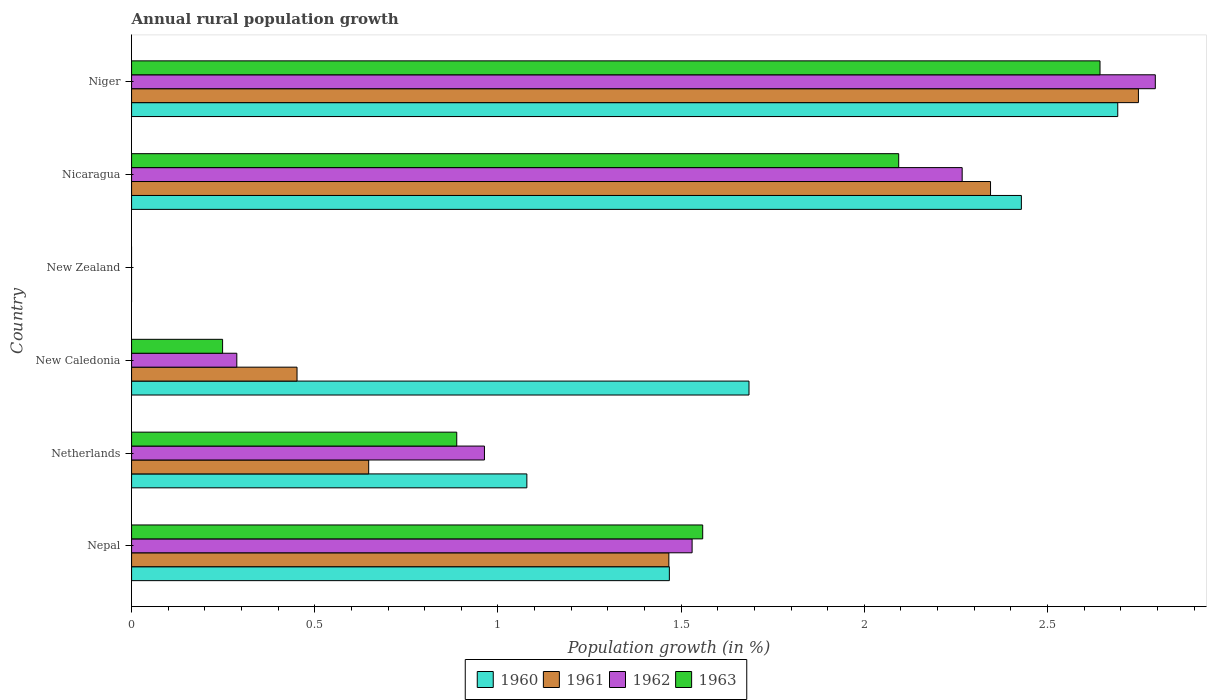How many different coloured bars are there?
Provide a short and direct response. 4. Are the number of bars per tick equal to the number of legend labels?
Provide a succinct answer. No. Are the number of bars on each tick of the Y-axis equal?
Offer a very short reply. No. How many bars are there on the 6th tick from the top?
Keep it short and to the point. 4. What is the label of the 4th group of bars from the top?
Give a very brief answer. New Caledonia. In how many cases, is the number of bars for a given country not equal to the number of legend labels?
Keep it short and to the point. 1. What is the percentage of rural population growth in 1963 in New Caledonia?
Ensure brevity in your answer.  0.25. Across all countries, what is the maximum percentage of rural population growth in 1962?
Give a very brief answer. 2.79. In which country was the percentage of rural population growth in 1962 maximum?
Ensure brevity in your answer.  Niger. What is the total percentage of rural population growth in 1963 in the graph?
Provide a succinct answer. 7.43. What is the difference between the percentage of rural population growth in 1963 in Netherlands and that in New Caledonia?
Provide a short and direct response. 0.64. What is the difference between the percentage of rural population growth in 1961 in New Zealand and the percentage of rural population growth in 1963 in New Caledonia?
Provide a short and direct response. -0.25. What is the average percentage of rural population growth in 1963 per country?
Ensure brevity in your answer.  1.24. What is the difference between the percentage of rural population growth in 1960 and percentage of rural population growth in 1962 in Niger?
Your answer should be compact. -0.1. What is the ratio of the percentage of rural population growth in 1962 in Nepal to that in New Caledonia?
Keep it short and to the point. 5.33. Is the difference between the percentage of rural population growth in 1960 in New Caledonia and Niger greater than the difference between the percentage of rural population growth in 1962 in New Caledonia and Niger?
Your response must be concise. Yes. What is the difference between the highest and the second highest percentage of rural population growth in 1963?
Keep it short and to the point. 0.55. What is the difference between the highest and the lowest percentage of rural population growth in 1960?
Make the answer very short. 2.69. In how many countries, is the percentage of rural population growth in 1961 greater than the average percentage of rural population growth in 1961 taken over all countries?
Offer a very short reply. 3. Is the sum of the percentage of rural population growth in 1961 in Netherlands and Nicaragua greater than the maximum percentage of rural population growth in 1963 across all countries?
Provide a succinct answer. Yes. Is it the case that in every country, the sum of the percentage of rural population growth in 1963 and percentage of rural population growth in 1962 is greater than the percentage of rural population growth in 1961?
Your answer should be very brief. No. How many bars are there?
Offer a terse response. 20. What is the difference between two consecutive major ticks on the X-axis?
Offer a terse response. 0.5. Are the values on the major ticks of X-axis written in scientific E-notation?
Give a very brief answer. No. Does the graph contain any zero values?
Your answer should be compact. Yes. Does the graph contain grids?
Provide a succinct answer. No. How many legend labels are there?
Your response must be concise. 4. What is the title of the graph?
Offer a terse response. Annual rural population growth. Does "1978" appear as one of the legend labels in the graph?
Your response must be concise. No. What is the label or title of the X-axis?
Your answer should be very brief. Population growth (in %). What is the Population growth (in %) of 1960 in Nepal?
Provide a succinct answer. 1.47. What is the Population growth (in %) of 1961 in Nepal?
Provide a short and direct response. 1.47. What is the Population growth (in %) of 1962 in Nepal?
Ensure brevity in your answer.  1.53. What is the Population growth (in %) in 1963 in Nepal?
Keep it short and to the point. 1.56. What is the Population growth (in %) in 1960 in Netherlands?
Your response must be concise. 1.08. What is the Population growth (in %) of 1961 in Netherlands?
Your answer should be compact. 0.65. What is the Population growth (in %) of 1962 in Netherlands?
Your response must be concise. 0.96. What is the Population growth (in %) in 1963 in Netherlands?
Give a very brief answer. 0.89. What is the Population growth (in %) in 1960 in New Caledonia?
Make the answer very short. 1.69. What is the Population growth (in %) of 1961 in New Caledonia?
Make the answer very short. 0.45. What is the Population growth (in %) in 1962 in New Caledonia?
Offer a terse response. 0.29. What is the Population growth (in %) of 1963 in New Caledonia?
Offer a terse response. 0.25. What is the Population growth (in %) of 1960 in New Zealand?
Give a very brief answer. 0. What is the Population growth (in %) of 1962 in New Zealand?
Make the answer very short. 0. What is the Population growth (in %) of 1963 in New Zealand?
Give a very brief answer. 0. What is the Population growth (in %) of 1960 in Nicaragua?
Your response must be concise. 2.43. What is the Population growth (in %) in 1961 in Nicaragua?
Your answer should be compact. 2.34. What is the Population growth (in %) in 1962 in Nicaragua?
Provide a short and direct response. 2.27. What is the Population growth (in %) of 1963 in Nicaragua?
Give a very brief answer. 2.09. What is the Population growth (in %) of 1960 in Niger?
Offer a very short reply. 2.69. What is the Population growth (in %) of 1961 in Niger?
Offer a terse response. 2.75. What is the Population growth (in %) in 1962 in Niger?
Your answer should be very brief. 2.79. What is the Population growth (in %) of 1963 in Niger?
Keep it short and to the point. 2.64. Across all countries, what is the maximum Population growth (in %) in 1960?
Ensure brevity in your answer.  2.69. Across all countries, what is the maximum Population growth (in %) of 1961?
Your answer should be compact. 2.75. Across all countries, what is the maximum Population growth (in %) in 1962?
Your response must be concise. 2.79. Across all countries, what is the maximum Population growth (in %) of 1963?
Your answer should be compact. 2.64. Across all countries, what is the minimum Population growth (in %) of 1961?
Make the answer very short. 0. Across all countries, what is the minimum Population growth (in %) in 1962?
Offer a terse response. 0. Across all countries, what is the minimum Population growth (in %) of 1963?
Your response must be concise. 0. What is the total Population growth (in %) of 1960 in the graph?
Offer a very short reply. 9.35. What is the total Population growth (in %) of 1961 in the graph?
Your answer should be compact. 7.66. What is the total Population growth (in %) of 1962 in the graph?
Provide a short and direct response. 7.84. What is the total Population growth (in %) in 1963 in the graph?
Make the answer very short. 7.43. What is the difference between the Population growth (in %) in 1960 in Nepal and that in Netherlands?
Keep it short and to the point. 0.39. What is the difference between the Population growth (in %) in 1961 in Nepal and that in Netherlands?
Keep it short and to the point. 0.82. What is the difference between the Population growth (in %) of 1962 in Nepal and that in Netherlands?
Make the answer very short. 0.57. What is the difference between the Population growth (in %) in 1963 in Nepal and that in Netherlands?
Your answer should be very brief. 0.67. What is the difference between the Population growth (in %) in 1960 in Nepal and that in New Caledonia?
Make the answer very short. -0.22. What is the difference between the Population growth (in %) of 1961 in Nepal and that in New Caledonia?
Offer a terse response. 1.01. What is the difference between the Population growth (in %) of 1962 in Nepal and that in New Caledonia?
Your answer should be compact. 1.24. What is the difference between the Population growth (in %) in 1963 in Nepal and that in New Caledonia?
Offer a very short reply. 1.31. What is the difference between the Population growth (in %) in 1960 in Nepal and that in Nicaragua?
Provide a succinct answer. -0.96. What is the difference between the Population growth (in %) in 1961 in Nepal and that in Nicaragua?
Your answer should be very brief. -0.88. What is the difference between the Population growth (in %) in 1962 in Nepal and that in Nicaragua?
Offer a very short reply. -0.74. What is the difference between the Population growth (in %) in 1963 in Nepal and that in Nicaragua?
Provide a succinct answer. -0.54. What is the difference between the Population growth (in %) of 1960 in Nepal and that in Niger?
Offer a terse response. -1.22. What is the difference between the Population growth (in %) of 1961 in Nepal and that in Niger?
Your answer should be compact. -1.28. What is the difference between the Population growth (in %) in 1962 in Nepal and that in Niger?
Provide a short and direct response. -1.26. What is the difference between the Population growth (in %) in 1963 in Nepal and that in Niger?
Ensure brevity in your answer.  -1.08. What is the difference between the Population growth (in %) in 1960 in Netherlands and that in New Caledonia?
Give a very brief answer. -0.61. What is the difference between the Population growth (in %) of 1961 in Netherlands and that in New Caledonia?
Ensure brevity in your answer.  0.2. What is the difference between the Population growth (in %) of 1962 in Netherlands and that in New Caledonia?
Make the answer very short. 0.68. What is the difference between the Population growth (in %) in 1963 in Netherlands and that in New Caledonia?
Offer a terse response. 0.64. What is the difference between the Population growth (in %) of 1960 in Netherlands and that in Nicaragua?
Offer a very short reply. -1.35. What is the difference between the Population growth (in %) of 1961 in Netherlands and that in Nicaragua?
Provide a short and direct response. -1.7. What is the difference between the Population growth (in %) of 1962 in Netherlands and that in Nicaragua?
Make the answer very short. -1.3. What is the difference between the Population growth (in %) in 1963 in Netherlands and that in Nicaragua?
Offer a very short reply. -1.21. What is the difference between the Population growth (in %) of 1960 in Netherlands and that in Niger?
Keep it short and to the point. -1.61. What is the difference between the Population growth (in %) in 1961 in Netherlands and that in Niger?
Provide a succinct answer. -2.1. What is the difference between the Population growth (in %) of 1962 in Netherlands and that in Niger?
Make the answer very short. -1.83. What is the difference between the Population growth (in %) of 1963 in Netherlands and that in Niger?
Provide a succinct answer. -1.76. What is the difference between the Population growth (in %) of 1960 in New Caledonia and that in Nicaragua?
Your answer should be compact. -0.74. What is the difference between the Population growth (in %) of 1961 in New Caledonia and that in Nicaragua?
Provide a succinct answer. -1.89. What is the difference between the Population growth (in %) of 1962 in New Caledonia and that in Nicaragua?
Give a very brief answer. -1.98. What is the difference between the Population growth (in %) of 1963 in New Caledonia and that in Nicaragua?
Offer a very short reply. -1.85. What is the difference between the Population growth (in %) of 1960 in New Caledonia and that in Niger?
Your answer should be compact. -1.01. What is the difference between the Population growth (in %) in 1961 in New Caledonia and that in Niger?
Provide a succinct answer. -2.3. What is the difference between the Population growth (in %) of 1962 in New Caledonia and that in Niger?
Offer a terse response. -2.51. What is the difference between the Population growth (in %) of 1963 in New Caledonia and that in Niger?
Offer a very short reply. -2.4. What is the difference between the Population growth (in %) in 1960 in Nicaragua and that in Niger?
Ensure brevity in your answer.  -0.26. What is the difference between the Population growth (in %) in 1961 in Nicaragua and that in Niger?
Make the answer very short. -0.4. What is the difference between the Population growth (in %) of 1962 in Nicaragua and that in Niger?
Offer a very short reply. -0.53. What is the difference between the Population growth (in %) of 1963 in Nicaragua and that in Niger?
Your response must be concise. -0.55. What is the difference between the Population growth (in %) of 1960 in Nepal and the Population growth (in %) of 1961 in Netherlands?
Provide a short and direct response. 0.82. What is the difference between the Population growth (in %) in 1960 in Nepal and the Population growth (in %) in 1962 in Netherlands?
Offer a very short reply. 0.5. What is the difference between the Population growth (in %) of 1960 in Nepal and the Population growth (in %) of 1963 in Netherlands?
Make the answer very short. 0.58. What is the difference between the Population growth (in %) in 1961 in Nepal and the Population growth (in %) in 1962 in Netherlands?
Keep it short and to the point. 0.5. What is the difference between the Population growth (in %) of 1961 in Nepal and the Population growth (in %) of 1963 in Netherlands?
Give a very brief answer. 0.58. What is the difference between the Population growth (in %) in 1962 in Nepal and the Population growth (in %) in 1963 in Netherlands?
Your answer should be compact. 0.64. What is the difference between the Population growth (in %) in 1960 in Nepal and the Population growth (in %) in 1961 in New Caledonia?
Give a very brief answer. 1.02. What is the difference between the Population growth (in %) of 1960 in Nepal and the Population growth (in %) of 1962 in New Caledonia?
Ensure brevity in your answer.  1.18. What is the difference between the Population growth (in %) in 1960 in Nepal and the Population growth (in %) in 1963 in New Caledonia?
Offer a very short reply. 1.22. What is the difference between the Population growth (in %) in 1961 in Nepal and the Population growth (in %) in 1962 in New Caledonia?
Offer a terse response. 1.18. What is the difference between the Population growth (in %) of 1961 in Nepal and the Population growth (in %) of 1963 in New Caledonia?
Keep it short and to the point. 1.22. What is the difference between the Population growth (in %) in 1962 in Nepal and the Population growth (in %) in 1963 in New Caledonia?
Ensure brevity in your answer.  1.28. What is the difference between the Population growth (in %) in 1960 in Nepal and the Population growth (in %) in 1961 in Nicaragua?
Give a very brief answer. -0.88. What is the difference between the Population growth (in %) in 1960 in Nepal and the Population growth (in %) in 1962 in Nicaragua?
Your answer should be very brief. -0.8. What is the difference between the Population growth (in %) in 1960 in Nepal and the Population growth (in %) in 1963 in Nicaragua?
Provide a short and direct response. -0.63. What is the difference between the Population growth (in %) of 1961 in Nepal and the Population growth (in %) of 1962 in Nicaragua?
Make the answer very short. -0.8. What is the difference between the Population growth (in %) of 1961 in Nepal and the Population growth (in %) of 1963 in Nicaragua?
Offer a very short reply. -0.63. What is the difference between the Population growth (in %) of 1962 in Nepal and the Population growth (in %) of 1963 in Nicaragua?
Make the answer very short. -0.56. What is the difference between the Population growth (in %) in 1960 in Nepal and the Population growth (in %) in 1961 in Niger?
Offer a terse response. -1.28. What is the difference between the Population growth (in %) in 1960 in Nepal and the Population growth (in %) in 1962 in Niger?
Your answer should be compact. -1.33. What is the difference between the Population growth (in %) of 1960 in Nepal and the Population growth (in %) of 1963 in Niger?
Keep it short and to the point. -1.18. What is the difference between the Population growth (in %) in 1961 in Nepal and the Population growth (in %) in 1962 in Niger?
Offer a very short reply. -1.33. What is the difference between the Population growth (in %) of 1961 in Nepal and the Population growth (in %) of 1963 in Niger?
Ensure brevity in your answer.  -1.18. What is the difference between the Population growth (in %) of 1962 in Nepal and the Population growth (in %) of 1963 in Niger?
Your answer should be compact. -1.11. What is the difference between the Population growth (in %) in 1960 in Netherlands and the Population growth (in %) in 1961 in New Caledonia?
Offer a terse response. 0.63. What is the difference between the Population growth (in %) of 1960 in Netherlands and the Population growth (in %) of 1962 in New Caledonia?
Your response must be concise. 0.79. What is the difference between the Population growth (in %) in 1960 in Netherlands and the Population growth (in %) in 1963 in New Caledonia?
Offer a terse response. 0.83. What is the difference between the Population growth (in %) of 1961 in Netherlands and the Population growth (in %) of 1962 in New Caledonia?
Keep it short and to the point. 0.36. What is the difference between the Population growth (in %) of 1961 in Netherlands and the Population growth (in %) of 1963 in New Caledonia?
Provide a succinct answer. 0.4. What is the difference between the Population growth (in %) in 1962 in Netherlands and the Population growth (in %) in 1963 in New Caledonia?
Provide a short and direct response. 0.71. What is the difference between the Population growth (in %) in 1960 in Netherlands and the Population growth (in %) in 1961 in Nicaragua?
Keep it short and to the point. -1.27. What is the difference between the Population growth (in %) in 1960 in Netherlands and the Population growth (in %) in 1962 in Nicaragua?
Give a very brief answer. -1.19. What is the difference between the Population growth (in %) in 1960 in Netherlands and the Population growth (in %) in 1963 in Nicaragua?
Keep it short and to the point. -1.01. What is the difference between the Population growth (in %) in 1961 in Netherlands and the Population growth (in %) in 1962 in Nicaragua?
Offer a very short reply. -1.62. What is the difference between the Population growth (in %) in 1961 in Netherlands and the Population growth (in %) in 1963 in Nicaragua?
Ensure brevity in your answer.  -1.45. What is the difference between the Population growth (in %) in 1962 in Netherlands and the Population growth (in %) in 1963 in Nicaragua?
Your answer should be compact. -1.13. What is the difference between the Population growth (in %) in 1960 in Netherlands and the Population growth (in %) in 1961 in Niger?
Your answer should be compact. -1.67. What is the difference between the Population growth (in %) of 1960 in Netherlands and the Population growth (in %) of 1962 in Niger?
Provide a succinct answer. -1.72. What is the difference between the Population growth (in %) in 1960 in Netherlands and the Population growth (in %) in 1963 in Niger?
Your answer should be very brief. -1.56. What is the difference between the Population growth (in %) of 1961 in Netherlands and the Population growth (in %) of 1962 in Niger?
Your response must be concise. -2.15. What is the difference between the Population growth (in %) in 1961 in Netherlands and the Population growth (in %) in 1963 in Niger?
Offer a very short reply. -2. What is the difference between the Population growth (in %) of 1962 in Netherlands and the Population growth (in %) of 1963 in Niger?
Provide a succinct answer. -1.68. What is the difference between the Population growth (in %) in 1960 in New Caledonia and the Population growth (in %) in 1961 in Nicaragua?
Offer a very short reply. -0.66. What is the difference between the Population growth (in %) in 1960 in New Caledonia and the Population growth (in %) in 1962 in Nicaragua?
Provide a short and direct response. -0.58. What is the difference between the Population growth (in %) in 1960 in New Caledonia and the Population growth (in %) in 1963 in Nicaragua?
Provide a succinct answer. -0.41. What is the difference between the Population growth (in %) of 1961 in New Caledonia and the Population growth (in %) of 1962 in Nicaragua?
Your answer should be very brief. -1.82. What is the difference between the Population growth (in %) of 1961 in New Caledonia and the Population growth (in %) of 1963 in Nicaragua?
Your answer should be compact. -1.64. What is the difference between the Population growth (in %) of 1962 in New Caledonia and the Population growth (in %) of 1963 in Nicaragua?
Your answer should be very brief. -1.81. What is the difference between the Population growth (in %) of 1960 in New Caledonia and the Population growth (in %) of 1961 in Niger?
Your answer should be compact. -1.06. What is the difference between the Population growth (in %) in 1960 in New Caledonia and the Population growth (in %) in 1962 in Niger?
Ensure brevity in your answer.  -1.11. What is the difference between the Population growth (in %) in 1960 in New Caledonia and the Population growth (in %) in 1963 in Niger?
Your answer should be very brief. -0.96. What is the difference between the Population growth (in %) in 1961 in New Caledonia and the Population growth (in %) in 1962 in Niger?
Keep it short and to the point. -2.34. What is the difference between the Population growth (in %) in 1961 in New Caledonia and the Population growth (in %) in 1963 in Niger?
Ensure brevity in your answer.  -2.19. What is the difference between the Population growth (in %) in 1962 in New Caledonia and the Population growth (in %) in 1963 in Niger?
Keep it short and to the point. -2.36. What is the difference between the Population growth (in %) in 1960 in Nicaragua and the Population growth (in %) in 1961 in Niger?
Keep it short and to the point. -0.32. What is the difference between the Population growth (in %) of 1960 in Nicaragua and the Population growth (in %) of 1962 in Niger?
Offer a very short reply. -0.37. What is the difference between the Population growth (in %) of 1960 in Nicaragua and the Population growth (in %) of 1963 in Niger?
Provide a succinct answer. -0.21. What is the difference between the Population growth (in %) of 1961 in Nicaragua and the Population growth (in %) of 1962 in Niger?
Your response must be concise. -0.45. What is the difference between the Population growth (in %) of 1961 in Nicaragua and the Population growth (in %) of 1963 in Niger?
Give a very brief answer. -0.3. What is the difference between the Population growth (in %) of 1962 in Nicaragua and the Population growth (in %) of 1963 in Niger?
Make the answer very short. -0.38. What is the average Population growth (in %) in 1960 per country?
Ensure brevity in your answer.  1.56. What is the average Population growth (in %) of 1961 per country?
Your answer should be compact. 1.28. What is the average Population growth (in %) in 1962 per country?
Ensure brevity in your answer.  1.31. What is the average Population growth (in %) in 1963 per country?
Offer a very short reply. 1.24. What is the difference between the Population growth (in %) in 1960 and Population growth (in %) in 1961 in Nepal?
Your answer should be very brief. 0. What is the difference between the Population growth (in %) of 1960 and Population growth (in %) of 1962 in Nepal?
Offer a terse response. -0.06. What is the difference between the Population growth (in %) in 1960 and Population growth (in %) in 1963 in Nepal?
Your response must be concise. -0.09. What is the difference between the Population growth (in %) in 1961 and Population growth (in %) in 1962 in Nepal?
Offer a terse response. -0.06. What is the difference between the Population growth (in %) of 1961 and Population growth (in %) of 1963 in Nepal?
Make the answer very short. -0.09. What is the difference between the Population growth (in %) in 1962 and Population growth (in %) in 1963 in Nepal?
Offer a terse response. -0.03. What is the difference between the Population growth (in %) of 1960 and Population growth (in %) of 1961 in Netherlands?
Ensure brevity in your answer.  0.43. What is the difference between the Population growth (in %) of 1960 and Population growth (in %) of 1962 in Netherlands?
Make the answer very short. 0.12. What is the difference between the Population growth (in %) of 1960 and Population growth (in %) of 1963 in Netherlands?
Offer a very short reply. 0.19. What is the difference between the Population growth (in %) of 1961 and Population growth (in %) of 1962 in Netherlands?
Your answer should be compact. -0.32. What is the difference between the Population growth (in %) of 1961 and Population growth (in %) of 1963 in Netherlands?
Keep it short and to the point. -0.24. What is the difference between the Population growth (in %) of 1962 and Population growth (in %) of 1963 in Netherlands?
Offer a terse response. 0.08. What is the difference between the Population growth (in %) of 1960 and Population growth (in %) of 1961 in New Caledonia?
Give a very brief answer. 1.23. What is the difference between the Population growth (in %) in 1960 and Population growth (in %) in 1962 in New Caledonia?
Offer a very short reply. 1.4. What is the difference between the Population growth (in %) in 1960 and Population growth (in %) in 1963 in New Caledonia?
Keep it short and to the point. 1.44. What is the difference between the Population growth (in %) in 1961 and Population growth (in %) in 1962 in New Caledonia?
Ensure brevity in your answer.  0.16. What is the difference between the Population growth (in %) in 1961 and Population growth (in %) in 1963 in New Caledonia?
Your response must be concise. 0.2. What is the difference between the Population growth (in %) in 1962 and Population growth (in %) in 1963 in New Caledonia?
Make the answer very short. 0.04. What is the difference between the Population growth (in %) of 1960 and Population growth (in %) of 1961 in Nicaragua?
Provide a short and direct response. 0.08. What is the difference between the Population growth (in %) in 1960 and Population growth (in %) in 1962 in Nicaragua?
Ensure brevity in your answer.  0.16. What is the difference between the Population growth (in %) of 1960 and Population growth (in %) of 1963 in Nicaragua?
Provide a succinct answer. 0.33. What is the difference between the Population growth (in %) of 1961 and Population growth (in %) of 1962 in Nicaragua?
Provide a succinct answer. 0.08. What is the difference between the Population growth (in %) of 1961 and Population growth (in %) of 1963 in Nicaragua?
Offer a very short reply. 0.25. What is the difference between the Population growth (in %) in 1962 and Population growth (in %) in 1963 in Nicaragua?
Ensure brevity in your answer.  0.17. What is the difference between the Population growth (in %) of 1960 and Population growth (in %) of 1961 in Niger?
Provide a succinct answer. -0.06. What is the difference between the Population growth (in %) in 1960 and Population growth (in %) in 1962 in Niger?
Make the answer very short. -0.1. What is the difference between the Population growth (in %) in 1960 and Population growth (in %) in 1963 in Niger?
Your response must be concise. 0.05. What is the difference between the Population growth (in %) in 1961 and Population growth (in %) in 1962 in Niger?
Offer a very short reply. -0.05. What is the difference between the Population growth (in %) in 1961 and Population growth (in %) in 1963 in Niger?
Give a very brief answer. 0.1. What is the difference between the Population growth (in %) of 1962 and Population growth (in %) of 1963 in Niger?
Make the answer very short. 0.15. What is the ratio of the Population growth (in %) of 1960 in Nepal to that in Netherlands?
Your answer should be compact. 1.36. What is the ratio of the Population growth (in %) of 1961 in Nepal to that in Netherlands?
Provide a succinct answer. 2.27. What is the ratio of the Population growth (in %) in 1962 in Nepal to that in Netherlands?
Your answer should be very brief. 1.59. What is the ratio of the Population growth (in %) of 1963 in Nepal to that in Netherlands?
Your answer should be very brief. 1.76. What is the ratio of the Population growth (in %) in 1960 in Nepal to that in New Caledonia?
Your answer should be compact. 0.87. What is the ratio of the Population growth (in %) in 1961 in Nepal to that in New Caledonia?
Give a very brief answer. 3.25. What is the ratio of the Population growth (in %) in 1962 in Nepal to that in New Caledonia?
Provide a short and direct response. 5.33. What is the ratio of the Population growth (in %) in 1963 in Nepal to that in New Caledonia?
Offer a very short reply. 6.28. What is the ratio of the Population growth (in %) of 1960 in Nepal to that in Nicaragua?
Give a very brief answer. 0.6. What is the ratio of the Population growth (in %) in 1961 in Nepal to that in Nicaragua?
Provide a short and direct response. 0.63. What is the ratio of the Population growth (in %) in 1962 in Nepal to that in Nicaragua?
Provide a succinct answer. 0.67. What is the ratio of the Population growth (in %) in 1963 in Nepal to that in Nicaragua?
Offer a terse response. 0.74. What is the ratio of the Population growth (in %) of 1960 in Nepal to that in Niger?
Your answer should be compact. 0.55. What is the ratio of the Population growth (in %) in 1961 in Nepal to that in Niger?
Ensure brevity in your answer.  0.53. What is the ratio of the Population growth (in %) of 1962 in Nepal to that in Niger?
Give a very brief answer. 0.55. What is the ratio of the Population growth (in %) in 1963 in Nepal to that in Niger?
Offer a terse response. 0.59. What is the ratio of the Population growth (in %) of 1960 in Netherlands to that in New Caledonia?
Make the answer very short. 0.64. What is the ratio of the Population growth (in %) of 1961 in Netherlands to that in New Caledonia?
Make the answer very short. 1.43. What is the ratio of the Population growth (in %) in 1962 in Netherlands to that in New Caledonia?
Keep it short and to the point. 3.35. What is the ratio of the Population growth (in %) in 1963 in Netherlands to that in New Caledonia?
Offer a very short reply. 3.57. What is the ratio of the Population growth (in %) of 1960 in Netherlands to that in Nicaragua?
Keep it short and to the point. 0.44. What is the ratio of the Population growth (in %) in 1961 in Netherlands to that in Nicaragua?
Keep it short and to the point. 0.28. What is the ratio of the Population growth (in %) in 1962 in Netherlands to that in Nicaragua?
Offer a terse response. 0.42. What is the ratio of the Population growth (in %) in 1963 in Netherlands to that in Nicaragua?
Give a very brief answer. 0.42. What is the ratio of the Population growth (in %) in 1960 in Netherlands to that in Niger?
Provide a short and direct response. 0.4. What is the ratio of the Population growth (in %) of 1961 in Netherlands to that in Niger?
Keep it short and to the point. 0.24. What is the ratio of the Population growth (in %) of 1962 in Netherlands to that in Niger?
Your answer should be compact. 0.34. What is the ratio of the Population growth (in %) of 1963 in Netherlands to that in Niger?
Your answer should be compact. 0.34. What is the ratio of the Population growth (in %) of 1960 in New Caledonia to that in Nicaragua?
Your response must be concise. 0.69. What is the ratio of the Population growth (in %) of 1961 in New Caledonia to that in Nicaragua?
Give a very brief answer. 0.19. What is the ratio of the Population growth (in %) of 1962 in New Caledonia to that in Nicaragua?
Ensure brevity in your answer.  0.13. What is the ratio of the Population growth (in %) of 1963 in New Caledonia to that in Nicaragua?
Your answer should be compact. 0.12. What is the ratio of the Population growth (in %) of 1960 in New Caledonia to that in Niger?
Your response must be concise. 0.63. What is the ratio of the Population growth (in %) in 1961 in New Caledonia to that in Niger?
Provide a succinct answer. 0.16. What is the ratio of the Population growth (in %) in 1962 in New Caledonia to that in Niger?
Give a very brief answer. 0.1. What is the ratio of the Population growth (in %) in 1963 in New Caledonia to that in Niger?
Keep it short and to the point. 0.09. What is the ratio of the Population growth (in %) of 1960 in Nicaragua to that in Niger?
Your answer should be very brief. 0.9. What is the ratio of the Population growth (in %) in 1961 in Nicaragua to that in Niger?
Provide a succinct answer. 0.85. What is the ratio of the Population growth (in %) in 1962 in Nicaragua to that in Niger?
Your answer should be compact. 0.81. What is the ratio of the Population growth (in %) in 1963 in Nicaragua to that in Niger?
Keep it short and to the point. 0.79. What is the difference between the highest and the second highest Population growth (in %) in 1960?
Give a very brief answer. 0.26. What is the difference between the highest and the second highest Population growth (in %) in 1961?
Your response must be concise. 0.4. What is the difference between the highest and the second highest Population growth (in %) of 1962?
Make the answer very short. 0.53. What is the difference between the highest and the second highest Population growth (in %) in 1963?
Ensure brevity in your answer.  0.55. What is the difference between the highest and the lowest Population growth (in %) in 1960?
Offer a very short reply. 2.69. What is the difference between the highest and the lowest Population growth (in %) in 1961?
Your response must be concise. 2.75. What is the difference between the highest and the lowest Population growth (in %) of 1962?
Keep it short and to the point. 2.79. What is the difference between the highest and the lowest Population growth (in %) of 1963?
Provide a short and direct response. 2.64. 